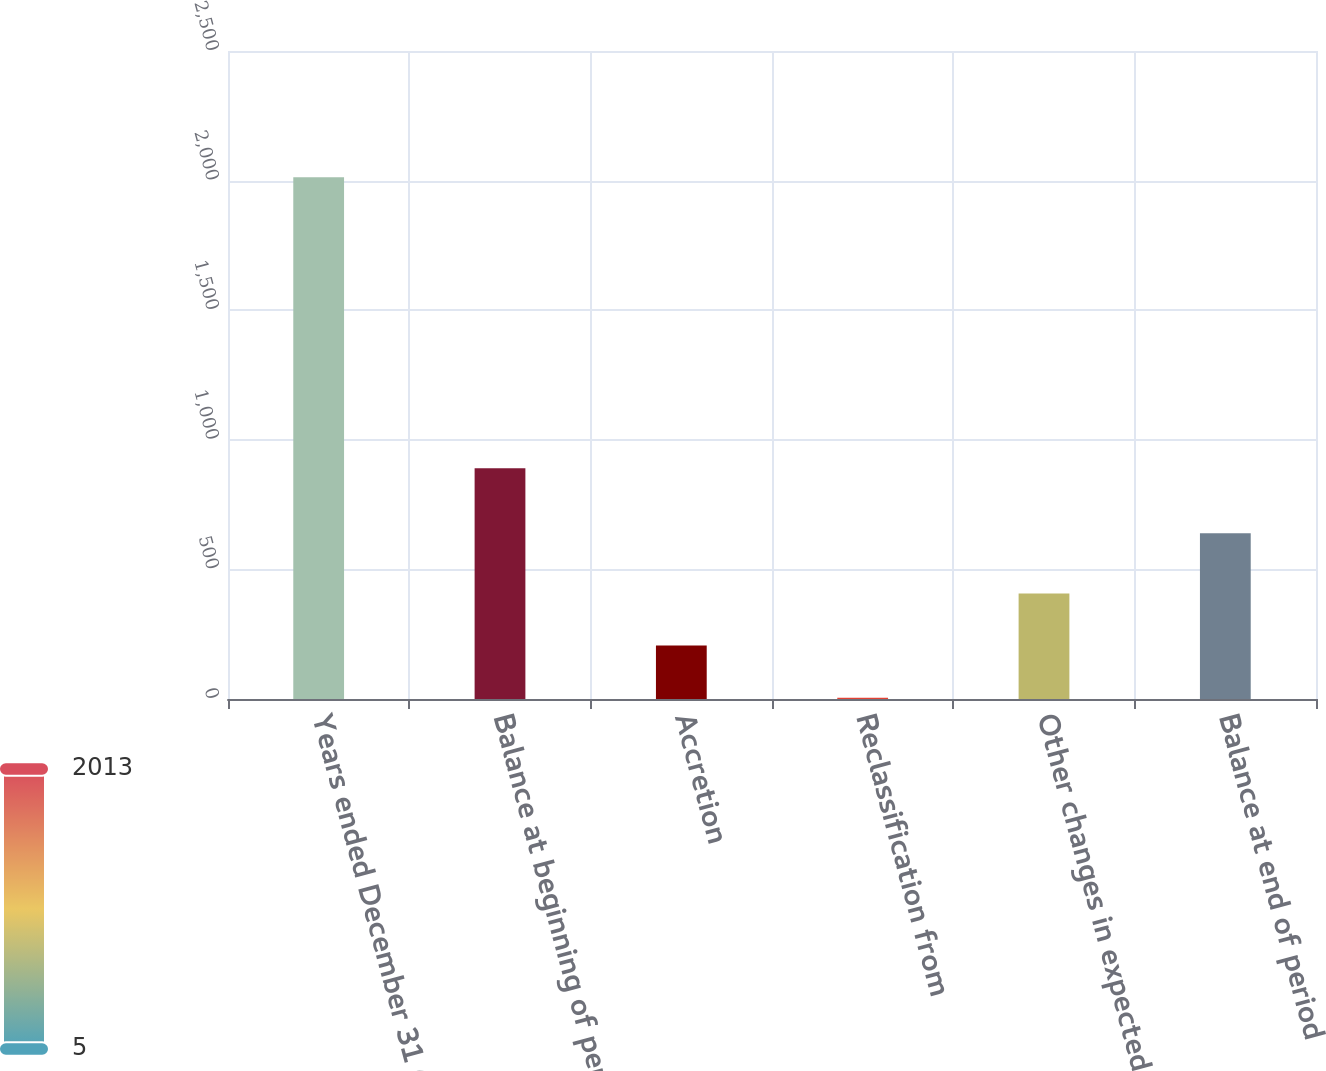Convert chart. <chart><loc_0><loc_0><loc_500><loc_500><bar_chart><fcel>Years ended December 31 (in<fcel>Balance at beginning of period<fcel>Accretion<fcel>Reclassification from<fcel>Other changes in expected cash<fcel>Balance at end of period<nl><fcel>2013<fcel>890.2<fcel>206.07<fcel>5.3<fcel>406.84<fcel>639.7<nl></chart> 